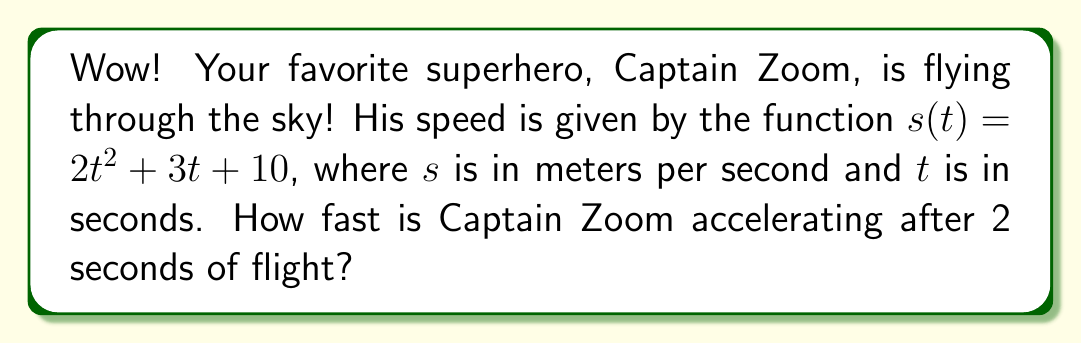Solve this math problem. Let's break this down step-by-step:

1) The speed function is $s(t) = 2t^2 + 3t + 10$.

2) To find the rate of change of speed (acceleration), we need to find the derivative of $s(t)$.

3) Using the power rule and constant rule of differentiation:
   $$\frac{d}{dt}(2t^2) = 2 \cdot 2t = 4t$$
   $$\frac{d}{dt}(3t) = 3$$
   $$\frac{d}{dt}(10) = 0$$

4) Combining these results, we get the derivative:
   $$s'(t) = 4t + 3$$

5) This function $s'(t)$ represents Captain Zoom's acceleration at any time $t$.

6) To find his acceleration after 2 seconds, we substitute $t=2$ into $s'(t)$:
   $$s'(2) = 4(2) + 3 = 8 + 3 = 11$$

Therefore, after 2 seconds, Captain Zoom is accelerating at 11 meters per second squared.
Answer: $11 \text{ m/s}^2$ 